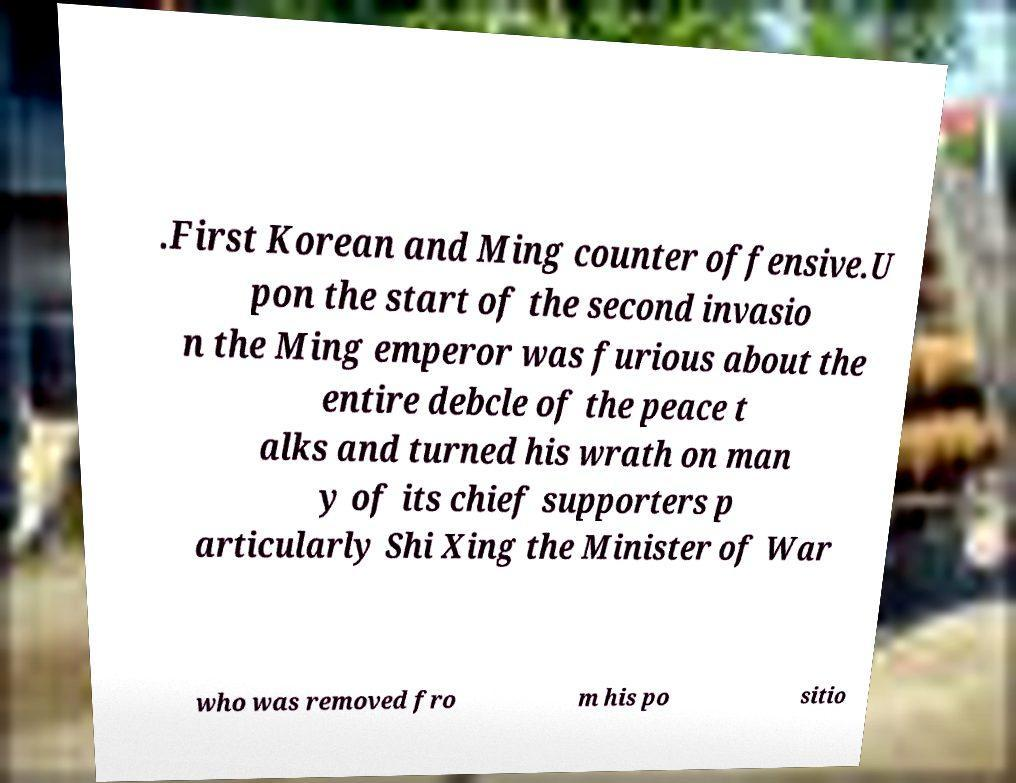Please identify and transcribe the text found in this image. .First Korean and Ming counter offensive.U pon the start of the second invasio n the Ming emperor was furious about the entire debcle of the peace t alks and turned his wrath on man y of its chief supporters p articularly Shi Xing the Minister of War who was removed fro m his po sitio 